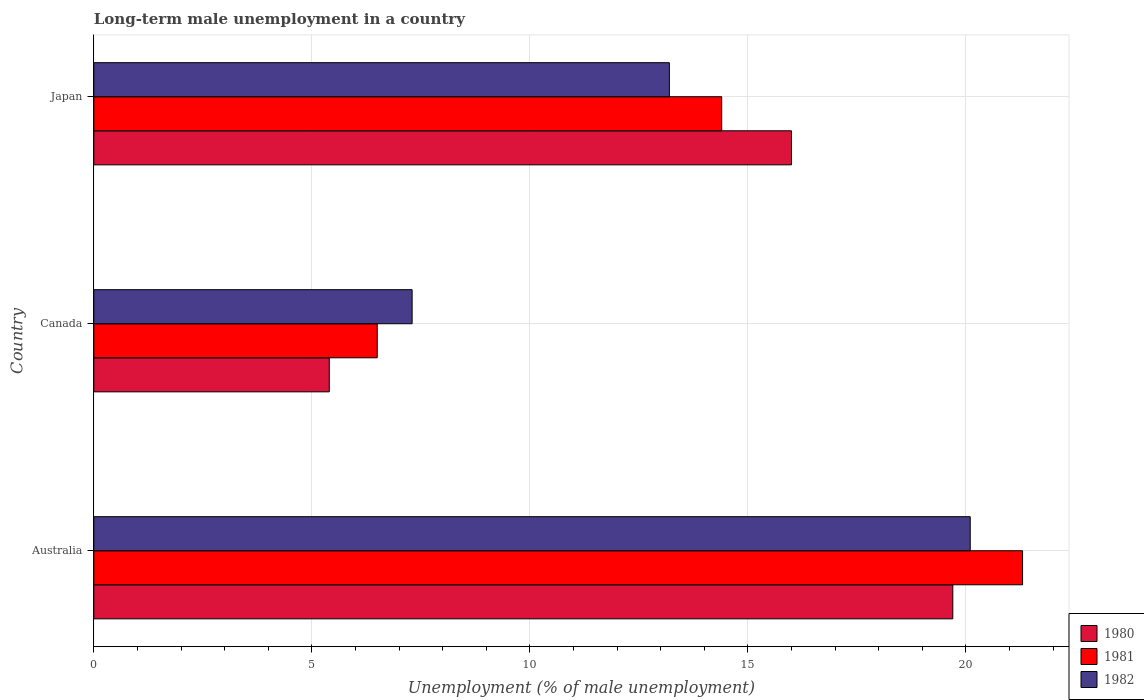How many different coloured bars are there?
Offer a very short reply. 3. Are the number of bars per tick equal to the number of legend labels?
Your answer should be very brief. Yes. How many bars are there on the 1st tick from the bottom?
Your response must be concise. 3. What is the label of the 2nd group of bars from the top?
Your answer should be very brief. Canada. What is the percentage of long-term unemployed male population in 1981 in Japan?
Provide a short and direct response. 14.4. Across all countries, what is the maximum percentage of long-term unemployed male population in 1982?
Make the answer very short. 20.1. Across all countries, what is the minimum percentage of long-term unemployed male population in 1981?
Your answer should be very brief. 6.5. In which country was the percentage of long-term unemployed male population in 1982 maximum?
Make the answer very short. Australia. In which country was the percentage of long-term unemployed male population in 1982 minimum?
Offer a terse response. Canada. What is the total percentage of long-term unemployed male population in 1982 in the graph?
Provide a succinct answer. 40.6. What is the difference between the percentage of long-term unemployed male population in 1982 in Canada and that in Japan?
Provide a succinct answer. -5.9. What is the difference between the percentage of long-term unemployed male population in 1981 in Canada and the percentage of long-term unemployed male population in 1982 in Australia?
Your answer should be compact. -13.6. What is the average percentage of long-term unemployed male population in 1981 per country?
Offer a very short reply. 14.07. What is the difference between the percentage of long-term unemployed male population in 1980 and percentage of long-term unemployed male population in 1981 in Australia?
Keep it short and to the point. -1.6. What is the ratio of the percentage of long-term unemployed male population in 1980 in Australia to that in Canada?
Keep it short and to the point. 3.65. What is the difference between the highest and the second highest percentage of long-term unemployed male population in 1980?
Offer a very short reply. 3.7. What is the difference between the highest and the lowest percentage of long-term unemployed male population in 1981?
Make the answer very short. 14.8. In how many countries, is the percentage of long-term unemployed male population in 1981 greater than the average percentage of long-term unemployed male population in 1981 taken over all countries?
Your response must be concise. 2. Is the sum of the percentage of long-term unemployed male population in 1982 in Canada and Japan greater than the maximum percentage of long-term unemployed male population in 1980 across all countries?
Keep it short and to the point. Yes. What does the 3rd bar from the bottom in Australia represents?
Provide a short and direct response. 1982. How many bars are there?
Your response must be concise. 9. Are all the bars in the graph horizontal?
Make the answer very short. Yes. What is the difference between two consecutive major ticks on the X-axis?
Keep it short and to the point. 5. Are the values on the major ticks of X-axis written in scientific E-notation?
Your response must be concise. No. Does the graph contain grids?
Keep it short and to the point. Yes. How many legend labels are there?
Keep it short and to the point. 3. How are the legend labels stacked?
Give a very brief answer. Vertical. What is the title of the graph?
Offer a terse response. Long-term male unemployment in a country. What is the label or title of the X-axis?
Offer a very short reply. Unemployment (% of male unemployment). What is the Unemployment (% of male unemployment) in 1980 in Australia?
Offer a terse response. 19.7. What is the Unemployment (% of male unemployment) of 1981 in Australia?
Offer a terse response. 21.3. What is the Unemployment (% of male unemployment) in 1982 in Australia?
Provide a short and direct response. 20.1. What is the Unemployment (% of male unemployment) of 1980 in Canada?
Ensure brevity in your answer.  5.4. What is the Unemployment (% of male unemployment) in 1982 in Canada?
Your response must be concise. 7.3. What is the Unemployment (% of male unemployment) in 1980 in Japan?
Provide a short and direct response. 16. What is the Unemployment (% of male unemployment) of 1981 in Japan?
Ensure brevity in your answer.  14.4. What is the Unemployment (% of male unemployment) of 1982 in Japan?
Your answer should be very brief. 13.2. Across all countries, what is the maximum Unemployment (% of male unemployment) in 1980?
Offer a terse response. 19.7. Across all countries, what is the maximum Unemployment (% of male unemployment) in 1981?
Offer a very short reply. 21.3. Across all countries, what is the maximum Unemployment (% of male unemployment) of 1982?
Provide a succinct answer. 20.1. Across all countries, what is the minimum Unemployment (% of male unemployment) in 1980?
Make the answer very short. 5.4. Across all countries, what is the minimum Unemployment (% of male unemployment) in 1982?
Provide a succinct answer. 7.3. What is the total Unemployment (% of male unemployment) of 1980 in the graph?
Make the answer very short. 41.1. What is the total Unemployment (% of male unemployment) of 1981 in the graph?
Offer a very short reply. 42.2. What is the total Unemployment (% of male unemployment) of 1982 in the graph?
Make the answer very short. 40.6. What is the difference between the Unemployment (% of male unemployment) of 1980 in Australia and that in Canada?
Provide a succinct answer. 14.3. What is the difference between the Unemployment (% of male unemployment) in 1981 in Australia and that in Canada?
Keep it short and to the point. 14.8. What is the difference between the Unemployment (% of male unemployment) of 1982 in Australia and that in Japan?
Your answer should be very brief. 6.9. What is the difference between the Unemployment (% of male unemployment) in 1980 in Canada and that in Japan?
Your answer should be compact. -10.6. What is the difference between the Unemployment (% of male unemployment) of 1980 in Australia and the Unemployment (% of male unemployment) of 1981 in Canada?
Make the answer very short. 13.2. What is the difference between the Unemployment (% of male unemployment) in 1981 in Australia and the Unemployment (% of male unemployment) in 1982 in Canada?
Provide a succinct answer. 14. What is the difference between the Unemployment (% of male unemployment) in 1980 in Australia and the Unemployment (% of male unemployment) in 1981 in Japan?
Offer a very short reply. 5.3. What is the difference between the Unemployment (% of male unemployment) of 1981 in Australia and the Unemployment (% of male unemployment) of 1982 in Japan?
Your response must be concise. 8.1. What is the difference between the Unemployment (% of male unemployment) of 1980 in Canada and the Unemployment (% of male unemployment) of 1981 in Japan?
Your answer should be compact. -9. What is the difference between the Unemployment (% of male unemployment) of 1980 in Canada and the Unemployment (% of male unemployment) of 1982 in Japan?
Ensure brevity in your answer.  -7.8. What is the difference between the Unemployment (% of male unemployment) of 1981 in Canada and the Unemployment (% of male unemployment) of 1982 in Japan?
Provide a succinct answer. -6.7. What is the average Unemployment (% of male unemployment) of 1981 per country?
Keep it short and to the point. 14.07. What is the average Unemployment (% of male unemployment) in 1982 per country?
Your answer should be compact. 13.53. What is the difference between the Unemployment (% of male unemployment) in 1980 and Unemployment (% of male unemployment) in 1981 in Australia?
Provide a short and direct response. -1.6. What is the difference between the Unemployment (% of male unemployment) in 1980 and Unemployment (% of male unemployment) in 1982 in Australia?
Your answer should be compact. -0.4. What is the difference between the Unemployment (% of male unemployment) of 1981 and Unemployment (% of male unemployment) of 1982 in Australia?
Keep it short and to the point. 1.2. What is the difference between the Unemployment (% of male unemployment) in 1980 and Unemployment (% of male unemployment) in 1981 in Canada?
Offer a very short reply. -1.1. What is the difference between the Unemployment (% of male unemployment) of 1980 and Unemployment (% of male unemployment) of 1982 in Canada?
Your answer should be compact. -1.9. What is the difference between the Unemployment (% of male unemployment) in 1981 and Unemployment (% of male unemployment) in 1982 in Canada?
Keep it short and to the point. -0.8. What is the difference between the Unemployment (% of male unemployment) of 1980 and Unemployment (% of male unemployment) of 1981 in Japan?
Offer a very short reply. 1.6. What is the difference between the Unemployment (% of male unemployment) of 1980 and Unemployment (% of male unemployment) of 1982 in Japan?
Provide a succinct answer. 2.8. What is the ratio of the Unemployment (% of male unemployment) of 1980 in Australia to that in Canada?
Make the answer very short. 3.65. What is the ratio of the Unemployment (% of male unemployment) in 1981 in Australia to that in Canada?
Your answer should be compact. 3.28. What is the ratio of the Unemployment (% of male unemployment) in 1982 in Australia to that in Canada?
Offer a terse response. 2.75. What is the ratio of the Unemployment (% of male unemployment) of 1980 in Australia to that in Japan?
Provide a succinct answer. 1.23. What is the ratio of the Unemployment (% of male unemployment) in 1981 in Australia to that in Japan?
Your answer should be compact. 1.48. What is the ratio of the Unemployment (% of male unemployment) of 1982 in Australia to that in Japan?
Your answer should be very brief. 1.52. What is the ratio of the Unemployment (% of male unemployment) in 1980 in Canada to that in Japan?
Your answer should be very brief. 0.34. What is the ratio of the Unemployment (% of male unemployment) in 1981 in Canada to that in Japan?
Ensure brevity in your answer.  0.45. What is the ratio of the Unemployment (% of male unemployment) in 1982 in Canada to that in Japan?
Offer a very short reply. 0.55. What is the difference between the highest and the second highest Unemployment (% of male unemployment) in 1980?
Offer a very short reply. 3.7. What is the difference between the highest and the second highest Unemployment (% of male unemployment) of 1982?
Give a very brief answer. 6.9. What is the difference between the highest and the lowest Unemployment (% of male unemployment) of 1981?
Offer a very short reply. 14.8. What is the difference between the highest and the lowest Unemployment (% of male unemployment) of 1982?
Give a very brief answer. 12.8. 